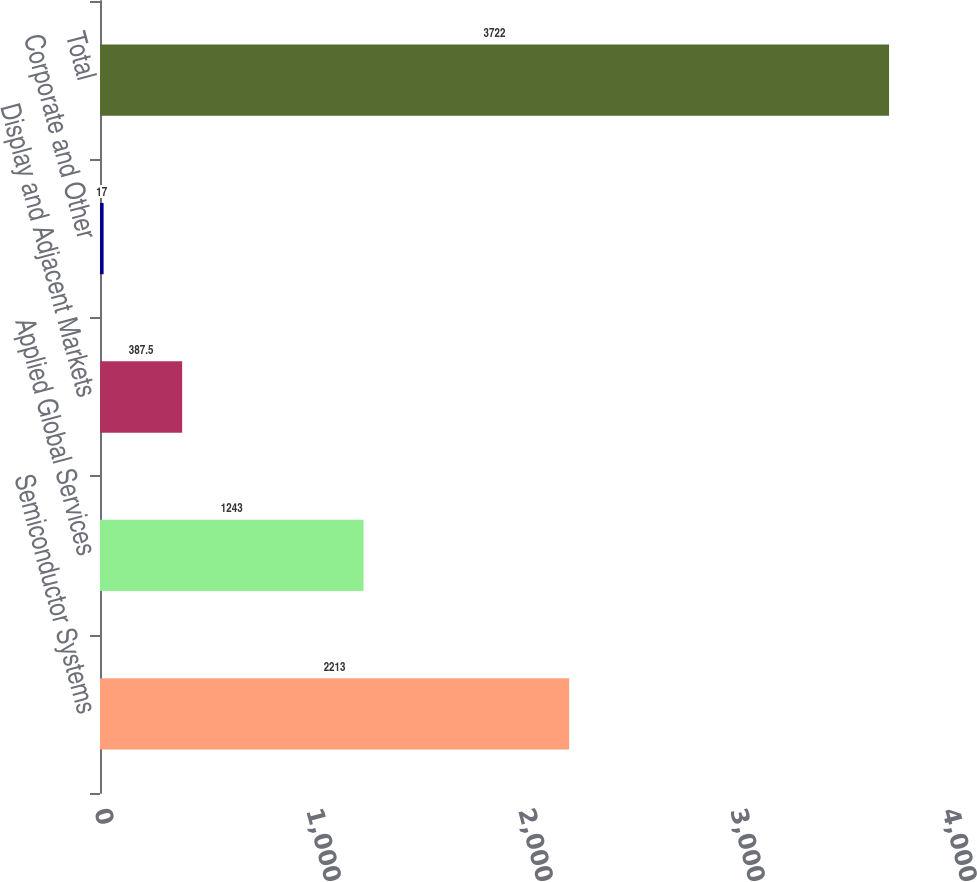Convert chart. <chart><loc_0><loc_0><loc_500><loc_500><bar_chart><fcel>Semiconductor Systems<fcel>Applied Global Services<fcel>Display and Adjacent Markets<fcel>Corporate and Other<fcel>Total<nl><fcel>2213<fcel>1243<fcel>387.5<fcel>17<fcel>3722<nl></chart> 